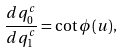<formula> <loc_0><loc_0><loc_500><loc_500>\frac { d q _ { 0 } ^ { c } } { d q _ { 1 } ^ { c } } = \cot { \phi { ( u ) } } ,</formula> 